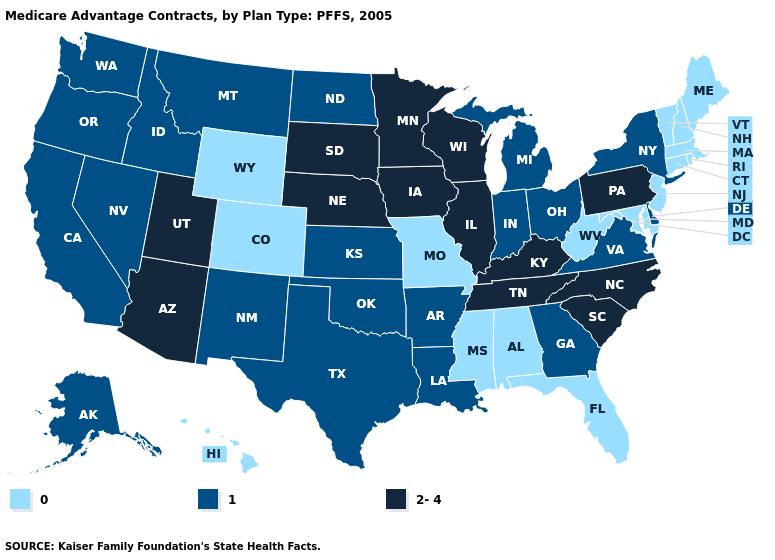Name the states that have a value in the range 1?
Keep it brief. Alaska, Arkansas, California, Delaware, Georgia, Idaho, Indiana, Kansas, Louisiana, Michigan, Montana, North Dakota, New Mexico, Nevada, New York, Ohio, Oklahoma, Oregon, Texas, Virginia, Washington. Does the map have missing data?
Keep it brief. No. Name the states that have a value in the range 0?
Answer briefly. Alabama, Colorado, Connecticut, Florida, Hawaii, Massachusetts, Maryland, Maine, Missouri, Mississippi, New Hampshire, New Jersey, Rhode Island, Vermont, West Virginia, Wyoming. Which states have the lowest value in the USA?
Give a very brief answer. Alabama, Colorado, Connecticut, Florida, Hawaii, Massachusetts, Maryland, Maine, Missouri, Mississippi, New Hampshire, New Jersey, Rhode Island, Vermont, West Virginia, Wyoming. Name the states that have a value in the range 0?
Keep it brief. Alabama, Colorado, Connecticut, Florida, Hawaii, Massachusetts, Maryland, Maine, Missouri, Mississippi, New Hampshire, New Jersey, Rhode Island, Vermont, West Virginia, Wyoming. What is the lowest value in states that border Georgia?
Answer briefly. 0. Name the states that have a value in the range 2-4?
Give a very brief answer. Arizona, Iowa, Illinois, Kentucky, Minnesota, North Carolina, Nebraska, Pennsylvania, South Carolina, South Dakota, Tennessee, Utah, Wisconsin. What is the value of Oregon?
Write a very short answer. 1. What is the value of Arkansas?
Concise answer only. 1. Name the states that have a value in the range 1?
Write a very short answer. Alaska, Arkansas, California, Delaware, Georgia, Idaho, Indiana, Kansas, Louisiana, Michigan, Montana, North Dakota, New Mexico, Nevada, New York, Ohio, Oklahoma, Oregon, Texas, Virginia, Washington. Does Maryland have a higher value than Arizona?
Give a very brief answer. No. How many symbols are there in the legend?
Give a very brief answer. 3. What is the highest value in states that border South Dakota?
Concise answer only. 2-4. Does Rhode Island have the same value as Wisconsin?
Be succinct. No. Name the states that have a value in the range 0?
Be succinct. Alabama, Colorado, Connecticut, Florida, Hawaii, Massachusetts, Maryland, Maine, Missouri, Mississippi, New Hampshire, New Jersey, Rhode Island, Vermont, West Virginia, Wyoming. 